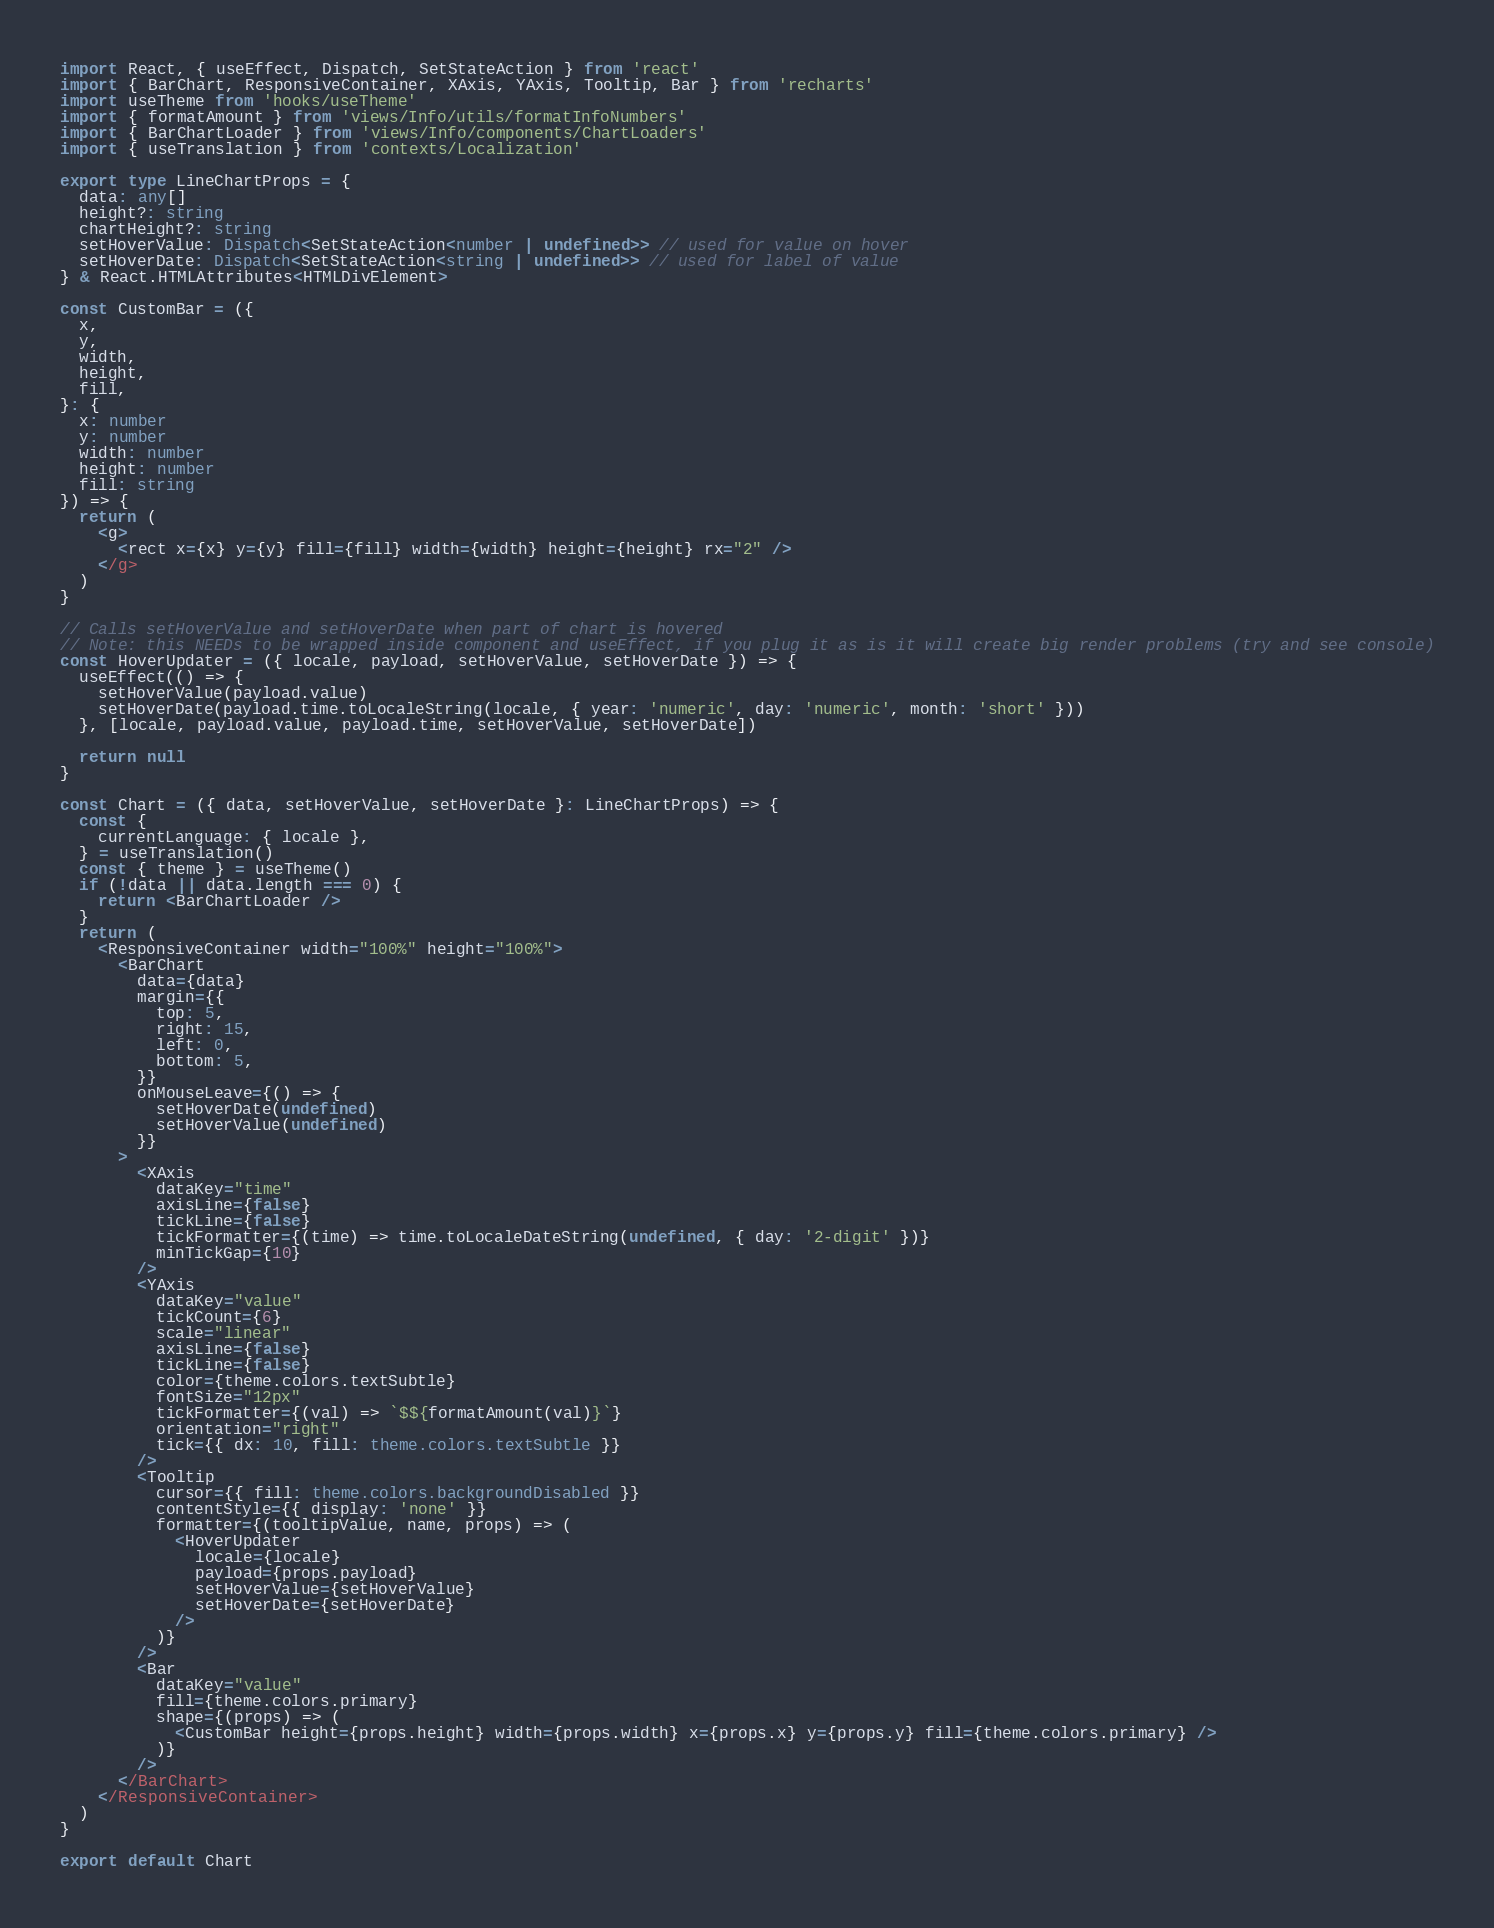Convert code to text. <code><loc_0><loc_0><loc_500><loc_500><_TypeScript_>import React, { useEffect, Dispatch, SetStateAction } from 'react'
import { BarChart, ResponsiveContainer, XAxis, YAxis, Tooltip, Bar } from 'recharts'
import useTheme from 'hooks/useTheme'
import { formatAmount } from 'views/Info/utils/formatInfoNumbers'
import { BarChartLoader } from 'views/Info/components/ChartLoaders'
import { useTranslation } from 'contexts/Localization'

export type LineChartProps = {
  data: any[]
  height?: string
  chartHeight?: string
  setHoverValue: Dispatch<SetStateAction<number | undefined>> // used for value on hover
  setHoverDate: Dispatch<SetStateAction<string | undefined>> // used for label of value
} & React.HTMLAttributes<HTMLDivElement>

const CustomBar = ({
  x,
  y,
  width,
  height,
  fill,
}: {
  x: number
  y: number
  width: number
  height: number
  fill: string
}) => {
  return (
    <g>
      <rect x={x} y={y} fill={fill} width={width} height={height} rx="2" />
    </g>
  )
}

// Calls setHoverValue and setHoverDate when part of chart is hovered
// Note: this NEEDs to be wrapped inside component and useEffect, if you plug it as is it will create big render problems (try and see console)
const HoverUpdater = ({ locale, payload, setHoverValue, setHoverDate }) => {
  useEffect(() => {
    setHoverValue(payload.value)
    setHoverDate(payload.time.toLocaleString(locale, { year: 'numeric', day: 'numeric', month: 'short' }))
  }, [locale, payload.value, payload.time, setHoverValue, setHoverDate])

  return null
}

const Chart = ({ data, setHoverValue, setHoverDate }: LineChartProps) => {
  const {
    currentLanguage: { locale },
  } = useTranslation()
  const { theme } = useTheme()
  if (!data || data.length === 0) {
    return <BarChartLoader />
  }
  return (
    <ResponsiveContainer width="100%" height="100%">
      <BarChart
        data={data}
        margin={{
          top: 5,
          right: 15,
          left: 0,
          bottom: 5,
        }}
        onMouseLeave={() => {
          setHoverDate(undefined)
          setHoverValue(undefined)
        }}
      >
        <XAxis
          dataKey="time"
          axisLine={false}
          tickLine={false}
          tickFormatter={(time) => time.toLocaleDateString(undefined, { day: '2-digit' })}
          minTickGap={10}
        />
        <YAxis
          dataKey="value"
          tickCount={6}
          scale="linear"
          axisLine={false}
          tickLine={false}
          color={theme.colors.textSubtle}
          fontSize="12px"
          tickFormatter={(val) => `$${formatAmount(val)}`}
          orientation="right"
          tick={{ dx: 10, fill: theme.colors.textSubtle }}
        />
        <Tooltip
          cursor={{ fill: theme.colors.backgroundDisabled }}
          contentStyle={{ display: 'none' }}
          formatter={(tooltipValue, name, props) => (
            <HoverUpdater
              locale={locale}
              payload={props.payload}
              setHoverValue={setHoverValue}
              setHoverDate={setHoverDate}
            />
          )}
        />
        <Bar
          dataKey="value"
          fill={theme.colors.primary}
          shape={(props) => (
            <CustomBar height={props.height} width={props.width} x={props.x} y={props.y} fill={theme.colors.primary} />
          )}
        />
      </BarChart>
    </ResponsiveContainer>
  )
}

export default Chart
</code> 